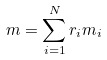Convert formula to latex. <formula><loc_0><loc_0><loc_500><loc_500>m = \sum _ { i = 1 } ^ { N } r _ { i } m _ { i }</formula> 